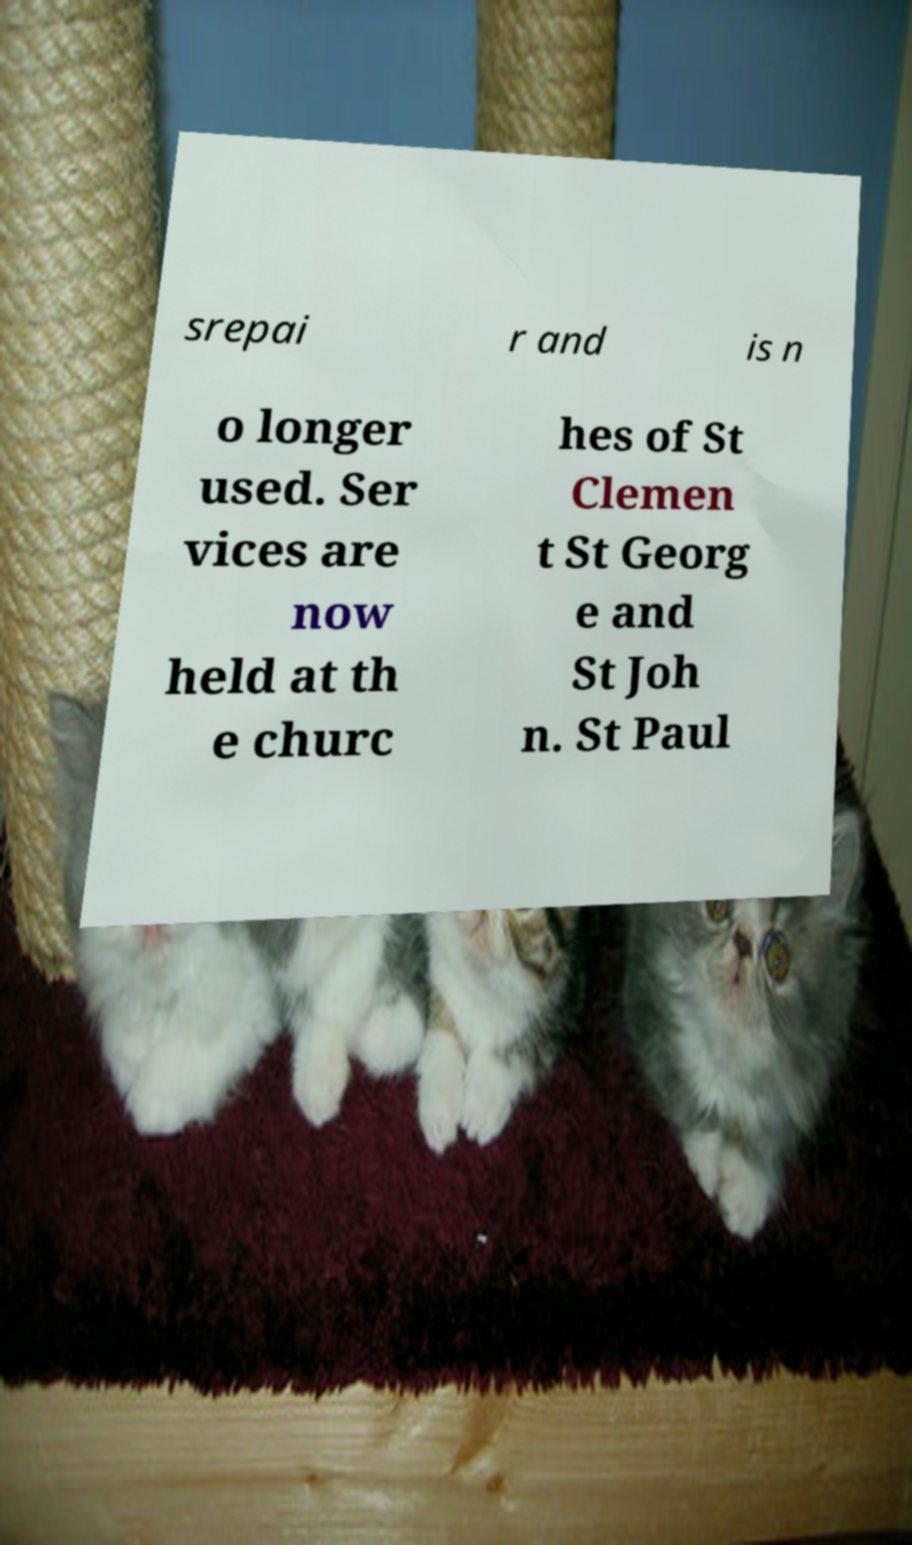Please identify and transcribe the text found in this image. srepai r and is n o longer used. Ser vices are now held at th e churc hes of St Clemen t St Georg e and St Joh n. St Paul 